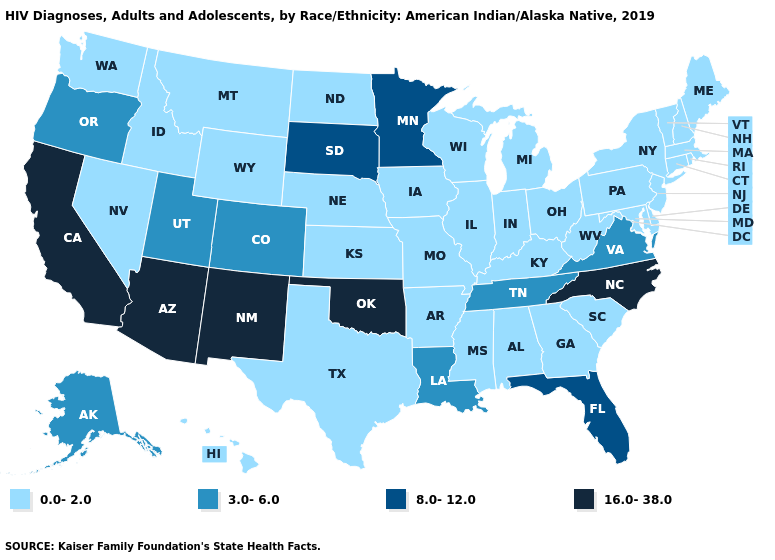Which states have the highest value in the USA?
Concise answer only. Arizona, California, New Mexico, North Carolina, Oklahoma. What is the value of South Dakota?
Write a very short answer. 8.0-12.0. Which states have the lowest value in the USA?
Short answer required. Alabama, Arkansas, Connecticut, Delaware, Georgia, Hawaii, Idaho, Illinois, Indiana, Iowa, Kansas, Kentucky, Maine, Maryland, Massachusetts, Michigan, Mississippi, Missouri, Montana, Nebraska, Nevada, New Hampshire, New Jersey, New York, North Dakota, Ohio, Pennsylvania, Rhode Island, South Carolina, Texas, Vermont, Washington, West Virginia, Wisconsin, Wyoming. Does the map have missing data?
Give a very brief answer. No. What is the lowest value in the MidWest?
Concise answer only. 0.0-2.0. Name the states that have a value in the range 8.0-12.0?
Quick response, please. Florida, Minnesota, South Dakota. What is the value of Ohio?
Be succinct. 0.0-2.0. Among the states that border Nevada , which have the lowest value?
Be succinct. Idaho. Name the states that have a value in the range 3.0-6.0?
Give a very brief answer. Alaska, Colorado, Louisiana, Oregon, Tennessee, Utah, Virginia. What is the value of Massachusetts?
Give a very brief answer. 0.0-2.0. What is the value of Delaware?
Concise answer only. 0.0-2.0. Does Arizona have the lowest value in the USA?
Concise answer only. No. What is the lowest value in the USA?
Keep it brief. 0.0-2.0. Name the states that have a value in the range 0.0-2.0?
Give a very brief answer. Alabama, Arkansas, Connecticut, Delaware, Georgia, Hawaii, Idaho, Illinois, Indiana, Iowa, Kansas, Kentucky, Maine, Maryland, Massachusetts, Michigan, Mississippi, Missouri, Montana, Nebraska, Nevada, New Hampshire, New Jersey, New York, North Dakota, Ohio, Pennsylvania, Rhode Island, South Carolina, Texas, Vermont, Washington, West Virginia, Wisconsin, Wyoming. 